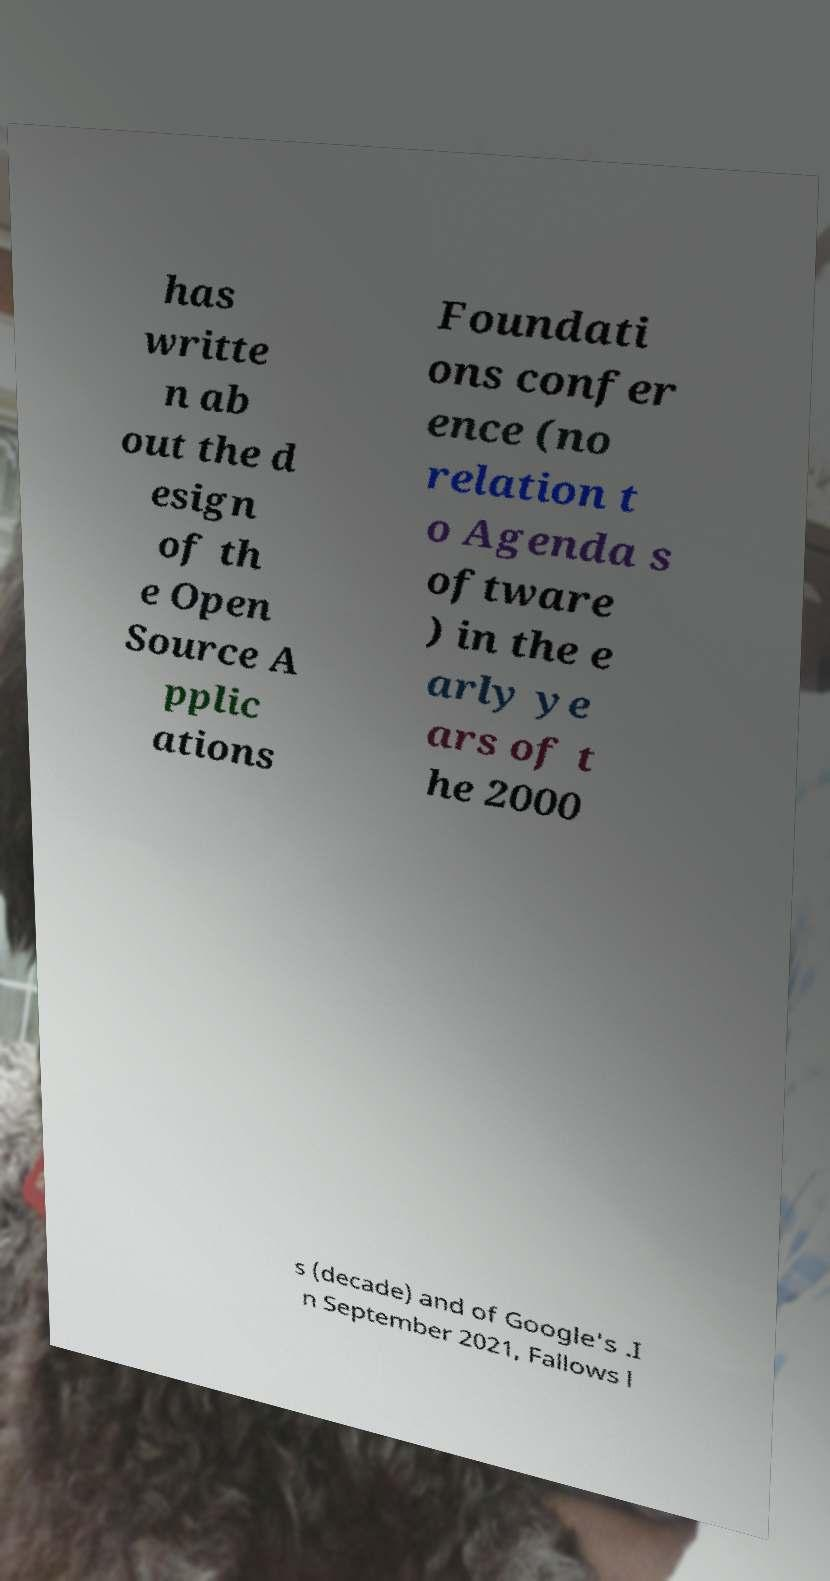For documentation purposes, I need the text within this image transcribed. Could you provide that? has writte n ab out the d esign of th e Open Source A pplic ations Foundati ons confer ence (no relation t o Agenda s oftware ) in the e arly ye ars of t he 2000 s (decade) and of Google's .I n September 2021, Fallows l 